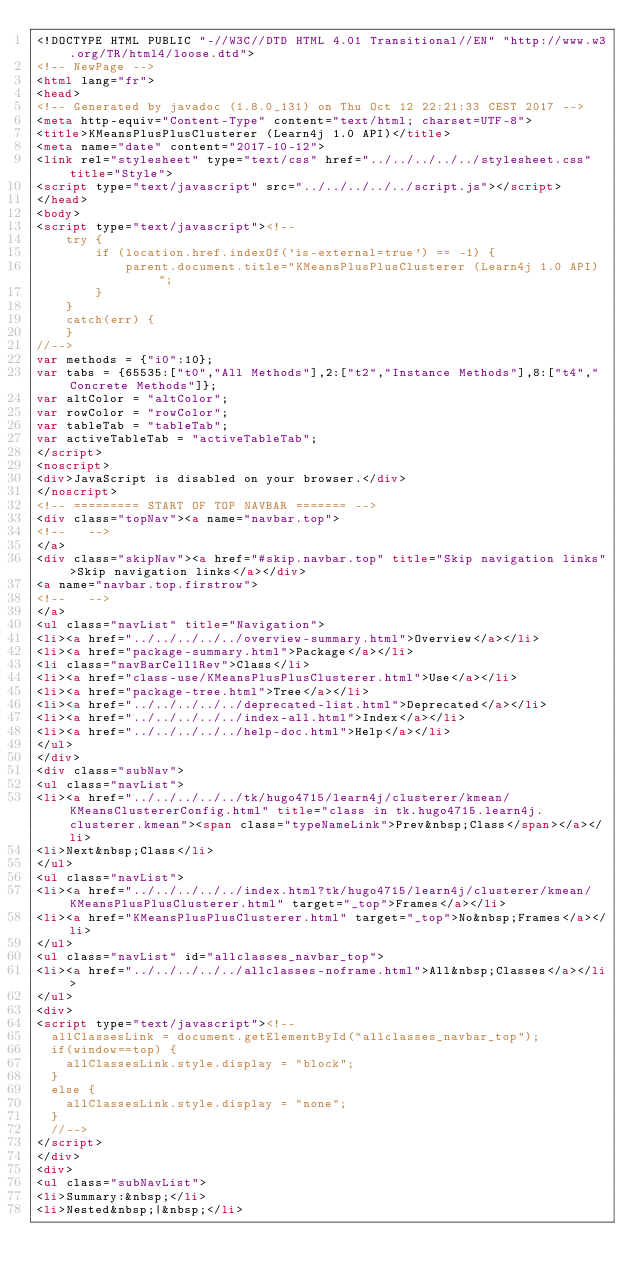<code> <loc_0><loc_0><loc_500><loc_500><_HTML_><!DOCTYPE HTML PUBLIC "-//W3C//DTD HTML 4.01 Transitional//EN" "http://www.w3.org/TR/html4/loose.dtd">
<!-- NewPage -->
<html lang="fr">
<head>
<!-- Generated by javadoc (1.8.0_131) on Thu Oct 12 22:21:33 CEST 2017 -->
<meta http-equiv="Content-Type" content="text/html; charset=UTF-8">
<title>KMeansPlusPlusClusterer (Learn4j 1.0 API)</title>
<meta name="date" content="2017-10-12">
<link rel="stylesheet" type="text/css" href="../../../../../stylesheet.css" title="Style">
<script type="text/javascript" src="../../../../../script.js"></script>
</head>
<body>
<script type="text/javascript"><!--
    try {
        if (location.href.indexOf('is-external=true') == -1) {
            parent.document.title="KMeansPlusPlusClusterer (Learn4j 1.0 API)";
        }
    }
    catch(err) {
    }
//-->
var methods = {"i0":10};
var tabs = {65535:["t0","All Methods"],2:["t2","Instance Methods"],8:["t4","Concrete Methods"]};
var altColor = "altColor";
var rowColor = "rowColor";
var tableTab = "tableTab";
var activeTableTab = "activeTableTab";
</script>
<noscript>
<div>JavaScript is disabled on your browser.</div>
</noscript>
<!-- ========= START OF TOP NAVBAR ======= -->
<div class="topNav"><a name="navbar.top">
<!--   -->
</a>
<div class="skipNav"><a href="#skip.navbar.top" title="Skip navigation links">Skip navigation links</a></div>
<a name="navbar.top.firstrow">
<!--   -->
</a>
<ul class="navList" title="Navigation">
<li><a href="../../../../../overview-summary.html">Overview</a></li>
<li><a href="package-summary.html">Package</a></li>
<li class="navBarCell1Rev">Class</li>
<li><a href="class-use/KMeansPlusPlusClusterer.html">Use</a></li>
<li><a href="package-tree.html">Tree</a></li>
<li><a href="../../../../../deprecated-list.html">Deprecated</a></li>
<li><a href="../../../../../index-all.html">Index</a></li>
<li><a href="../../../../../help-doc.html">Help</a></li>
</ul>
</div>
<div class="subNav">
<ul class="navList">
<li><a href="../../../../../tk/hugo4715/learn4j/clusterer/kmean/KMeansClustererConfig.html" title="class in tk.hugo4715.learn4j.clusterer.kmean"><span class="typeNameLink">Prev&nbsp;Class</span></a></li>
<li>Next&nbsp;Class</li>
</ul>
<ul class="navList">
<li><a href="../../../../../index.html?tk/hugo4715/learn4j/clusterer/kmean/KMeansPlusPlusClusterer.html" target="_top">Frames</a></li>
<li><a href="KMeansPlusPlusClusterer.html" target="_top">No&nbsp;Frames</a></li>
</ul>
<ul class="navList" id="allclasses_navbar_top">
<li><a href="../../../../../allclasses-noframe.html">All&nbsp;Classes</a></li>
</ul>
<div>
<script type="text/javascript"><!--
  allClassesLink = document.getElementById("allclasses_navbar_top");
  if(window==top) {
    allClassesLink.style.display = "block";
  }
  else {
    allClassesLink.style.display = "none";
  }
  //-->
</script>
</div>
<div>
<ul class="subNavList">
<li>Summary:&nbsp;</li>
<li>Nested&nbsp;|&nbsp;</li></code> 